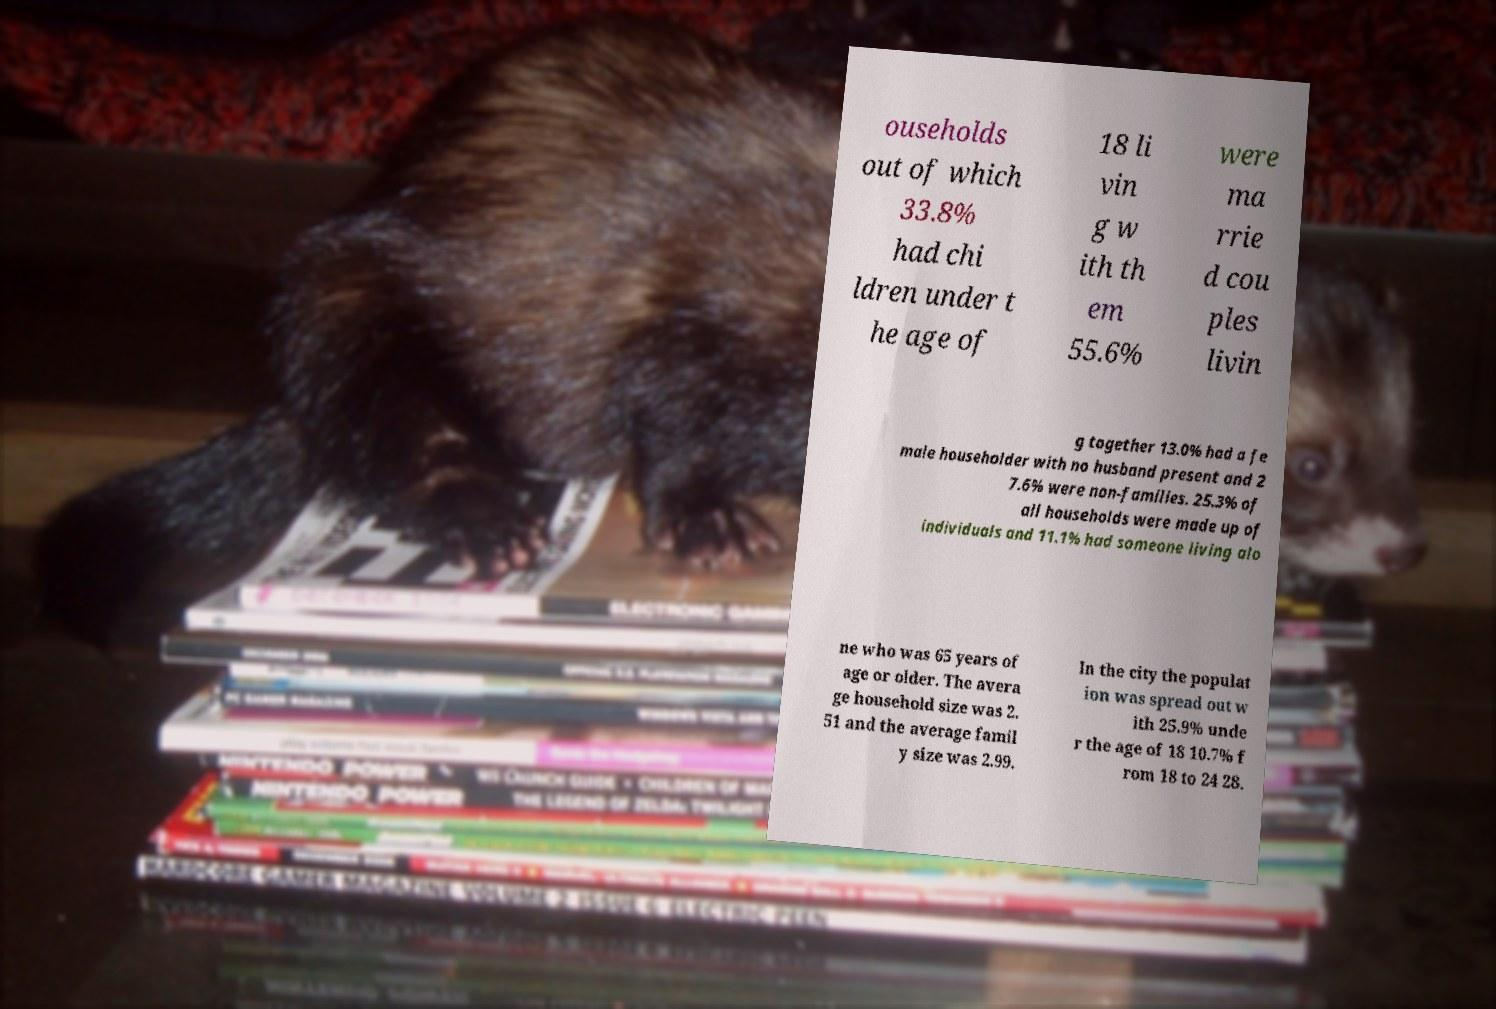Can you read and provide the text displayed in the image?This photo seems to have some interesting text. Can you extract and type it out for me? ouseholds out of which 33.8% had chi ldren under t he age of 18 li vin g w ith th em 55.6% were ma rrie d cou ples livin g together 13.0% had a fe male householder with no husband present and 2 7.6% were non-families. 25.3% of all households were made up of individuals and 11.1% had someone living alo ne who was 65 years of age or older. The avera ge household size was 2. 51 and the average famil y size was 2.99. In the city the populat ion was spread out w ith 25.9% unde r the age of 18 10.7% f rom 18 to 24 28. 